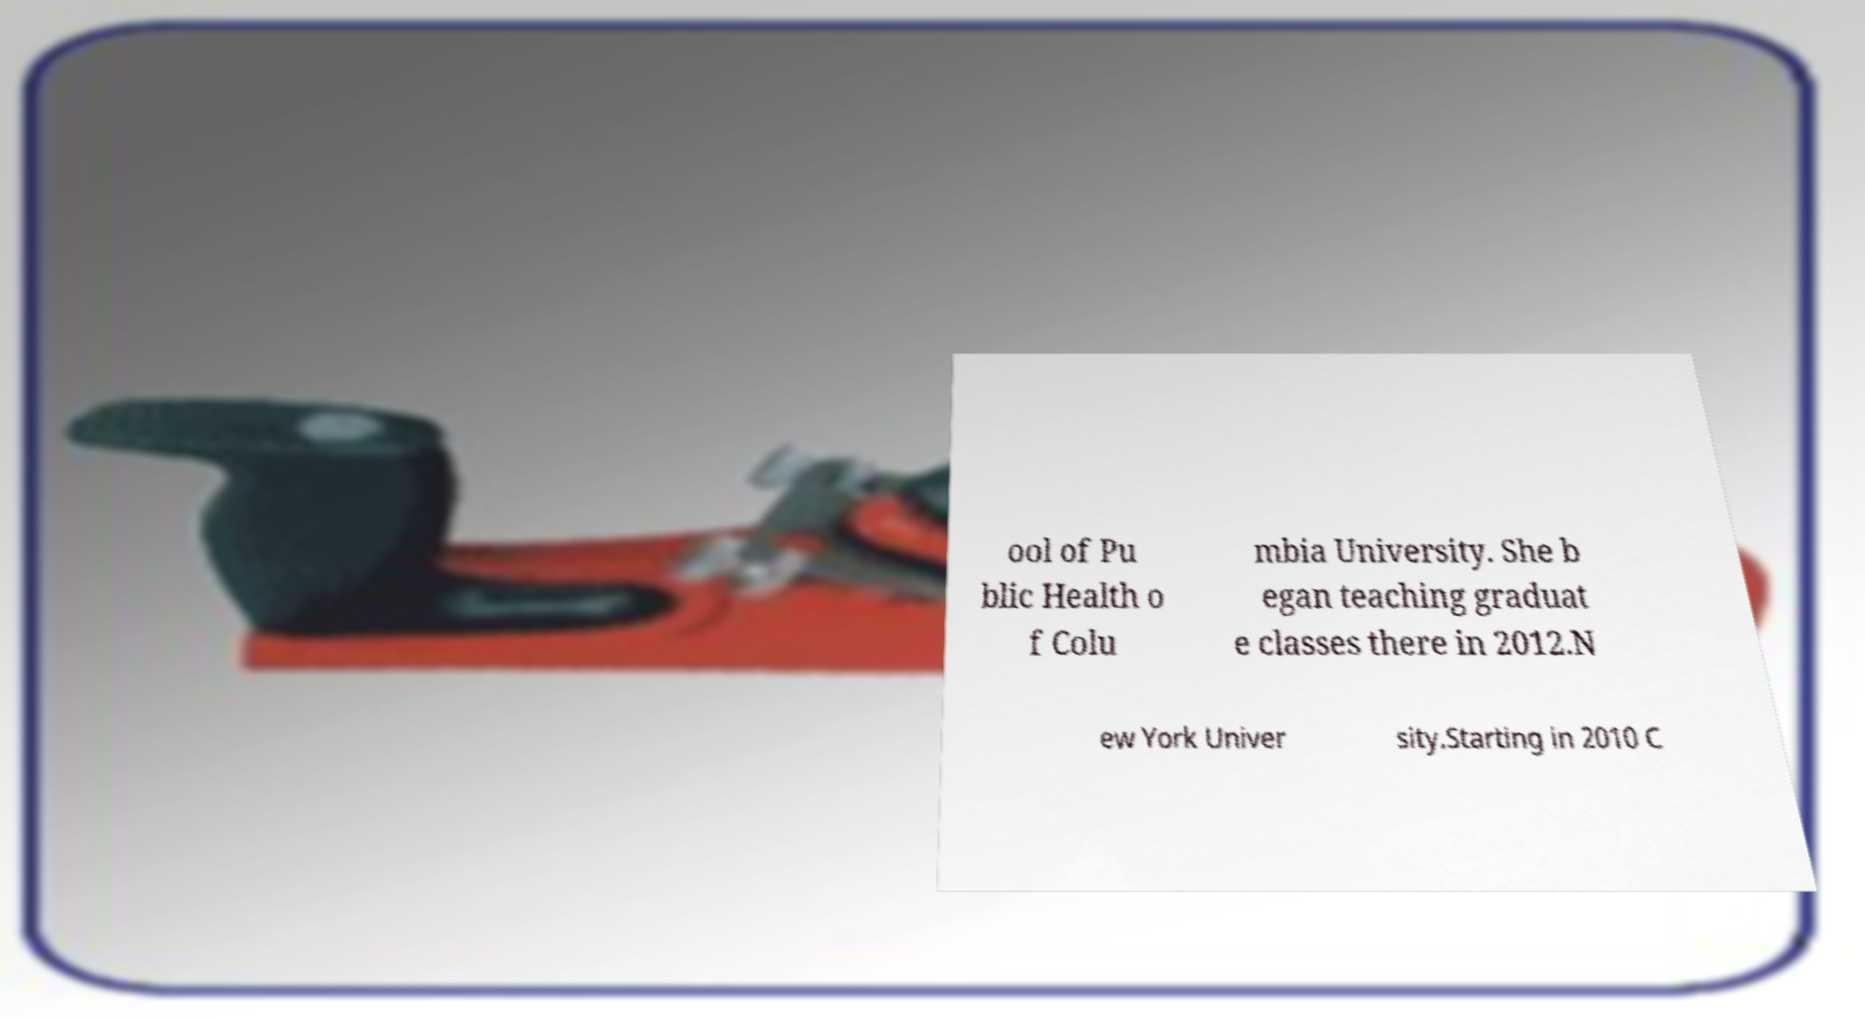There's text embedded in this image that I need extracted. Can you transcribe it verbatim? ool of Pu blic Health o f Colu mbia University. She b egan teaching graduat e classes there in 2012.N ew York Univer sity.Starting in 2010 C 